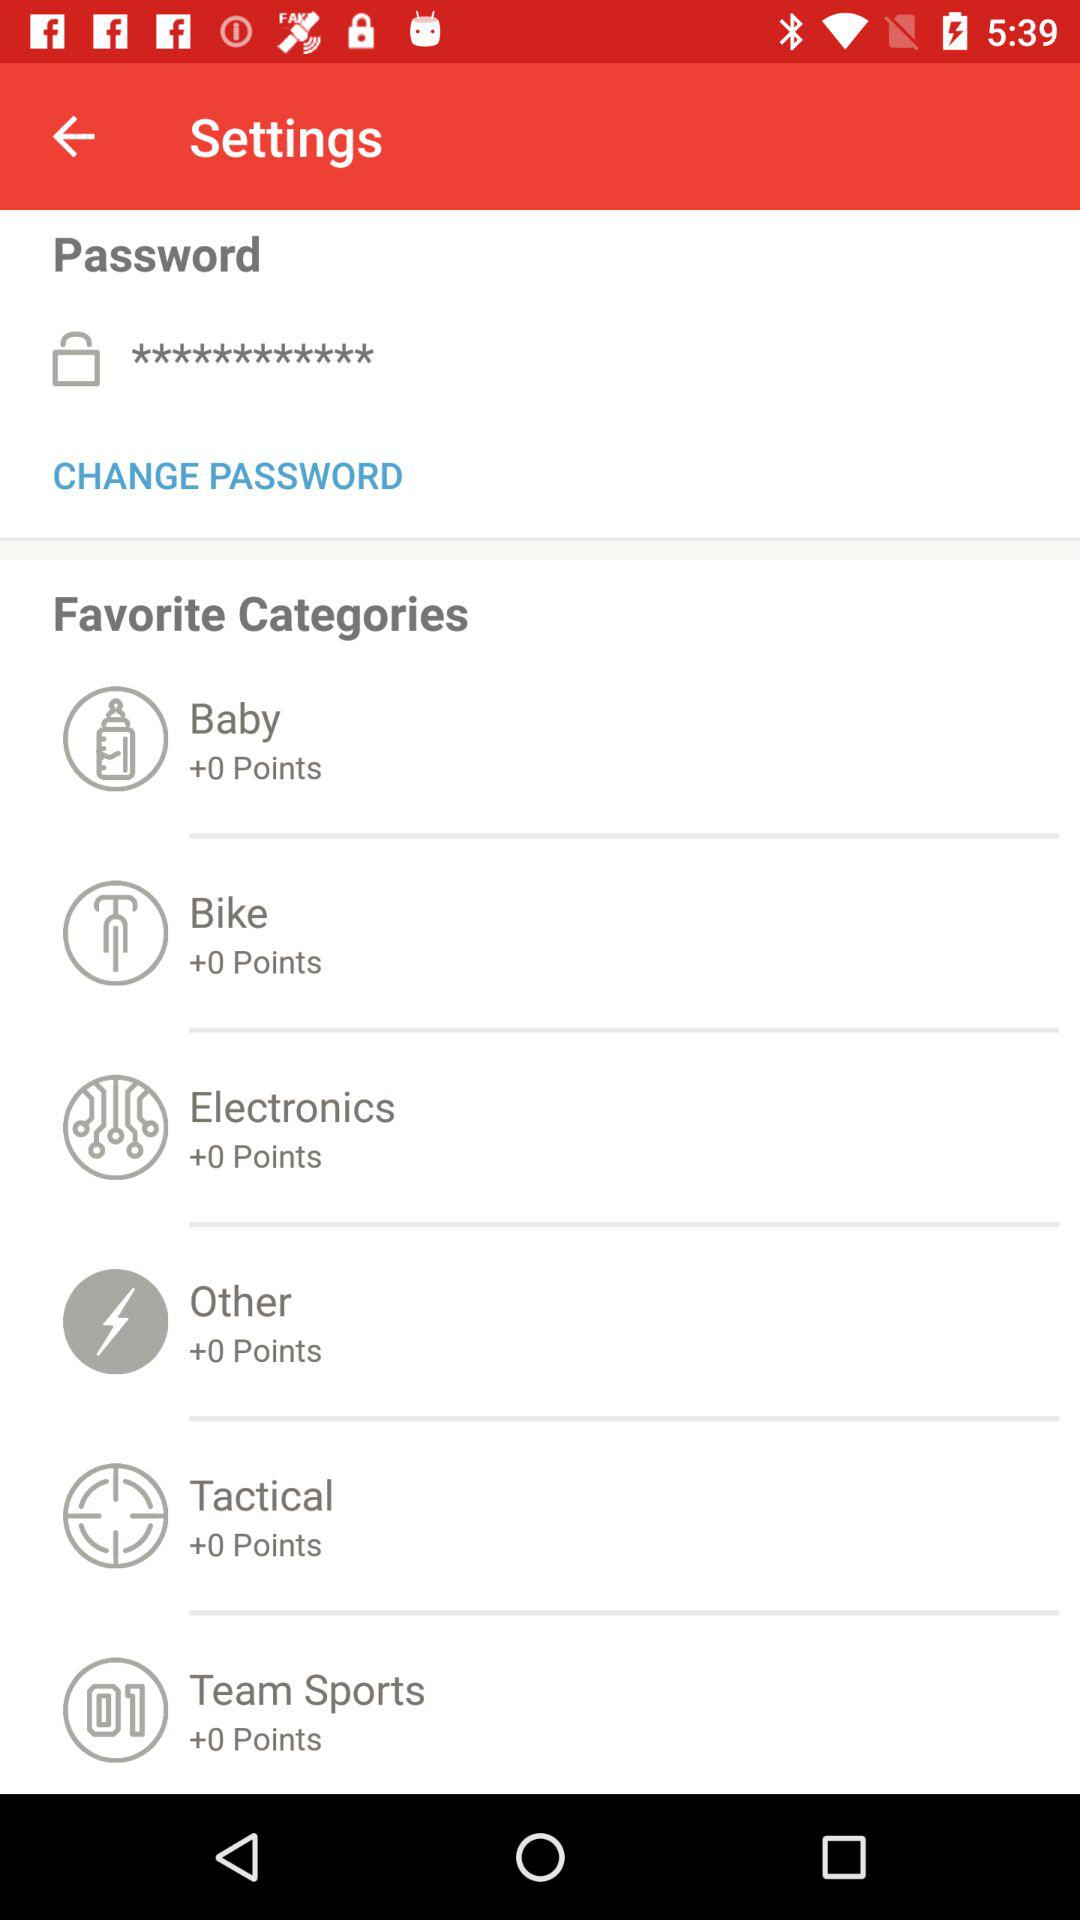How many points are there in "Electronics"? There are 0 points in "Electronics". 